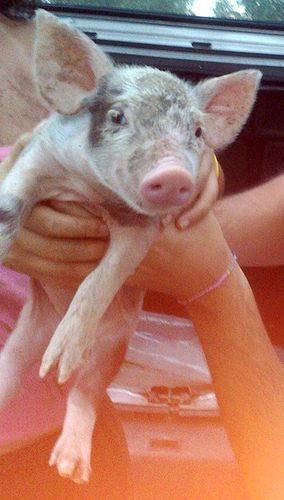<image>
Is the bracelet on the woman? Yes. Looking at the image, I can see the bracelet is positioned on top of the woman, with the woman providing support. 